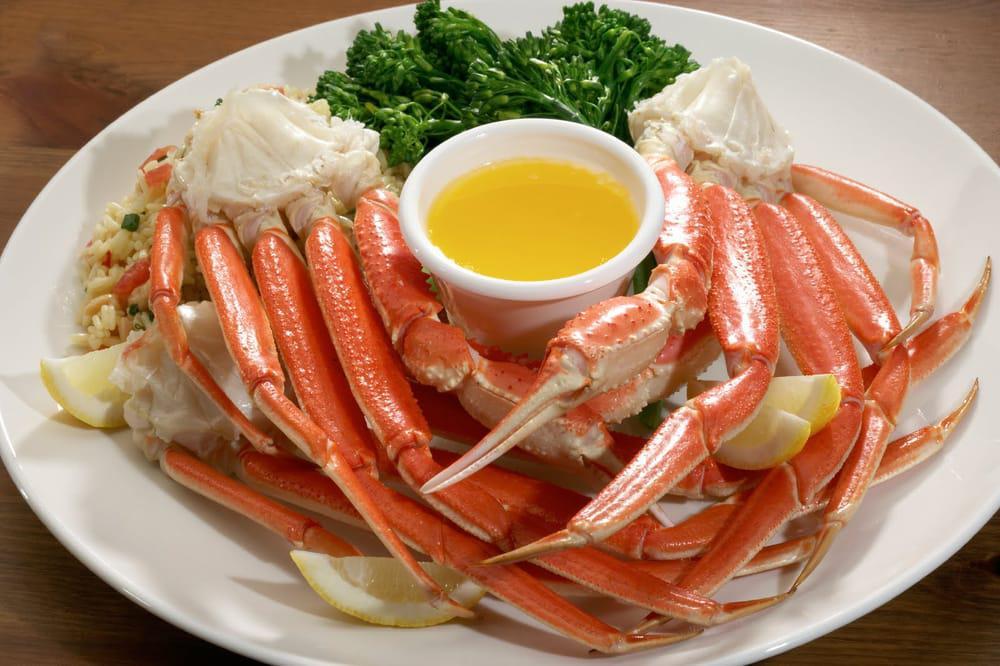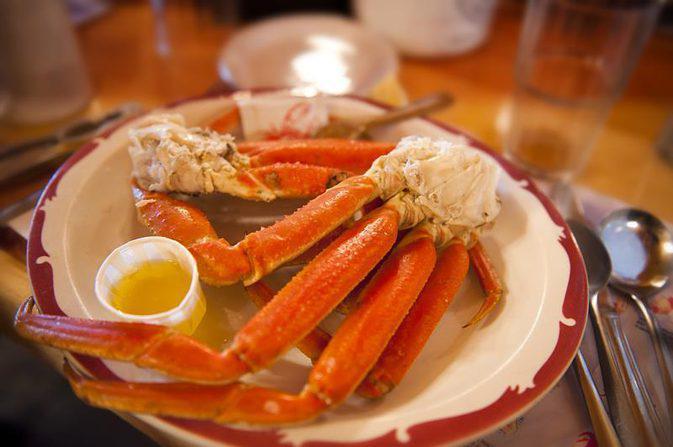The first image is the image on the left, the second image is the image on the right. Examine the images to the left and right. Is the description "In at least one image there is a total of five crab legs." accurate? Answer yes or no. No. 